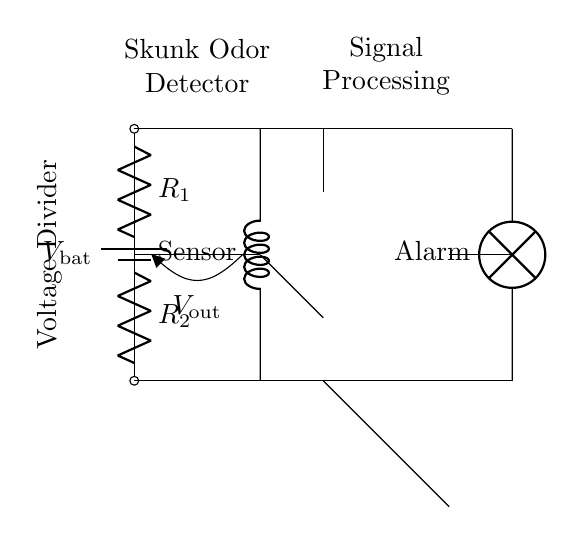What is the function of the voltage divider? The voltage divider reduces the input voltage from the battery to a lower output voltage for the sensor. It's formed by two resistors that split the voltage depending on their resistance values.
Answer: Reduces voltage What components are in the voltage divider? The voltage divider consists of two resistors, denoted as R1 and R2, connected in series between the battery voltage and ground.
Answer: Two resistors What is the purpose of the amplifier in the circuit? The amplifier strengthens the signal from the sensor, making it more suitable for triggering the alarm. It processes the low-level signal for detection.
Answer: Signal strengthening What is the output voltage labeled as? The output voltage from the voltage divider is labeled as Vout, indicating the voltage that will feed into the sensor.
Answer: Vout How does the alarm get activated? The alarm is activated by the output from the amplifier; if the amplified signal exceeds the threshold, it turns on the lamp, indicating detection of skunk odor.
Answer: Through the amplifier What role does the battery play in this circuit? The battery provides the necessary power supply for the entire circuit, ensuring that all components function correctly.
Answer: Power supply 